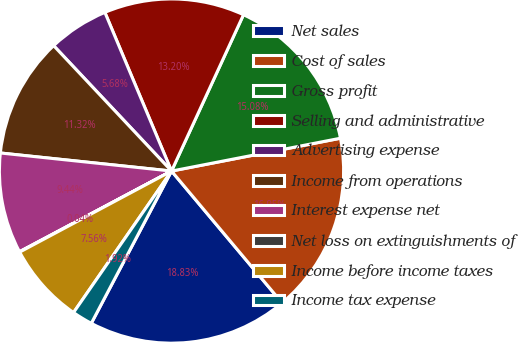Convert chart. <chart><loc_0><loc_0><loc_500><loc_500><pie_chart><fcel>Net sales<fcel>Cost of sales<fcel>Gross profit<fcel>Selling and administrative<fcel>Advertising expense<fcel>Income from operations<fcel>Interest expense net<fcel>Net loss on extinguishments of<fcel>Income before income taxes<fcel>Income tax expense<nl><fcel>18.83%<fcel>16.95%<fcel>15.08%<fcel>13.2%<fcel>5.68%<fcel>11.32%<fcel>9.44%<fcel>0.04%<fcel>7.56%<fcel>1.92%<nl></chart> 